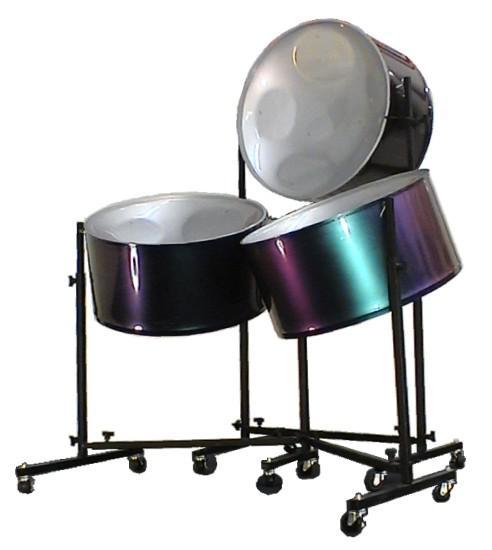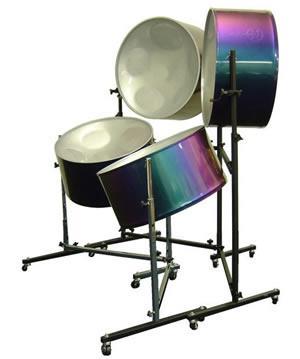The first image is the image on the left, the second image is the image on the right. For the images displayed, is the sentence "There are 7 drums total." factually correct? Answer yes or no. Yes. The first image is the image on the left, the second image is the image on the right. Given the left and right images, does the statement "Each image features a drum style with a concave top mounted on a pivoting stand, but one image contains one fewer bowl drum than the other image." hold true? Answer yes or no. Yes. 